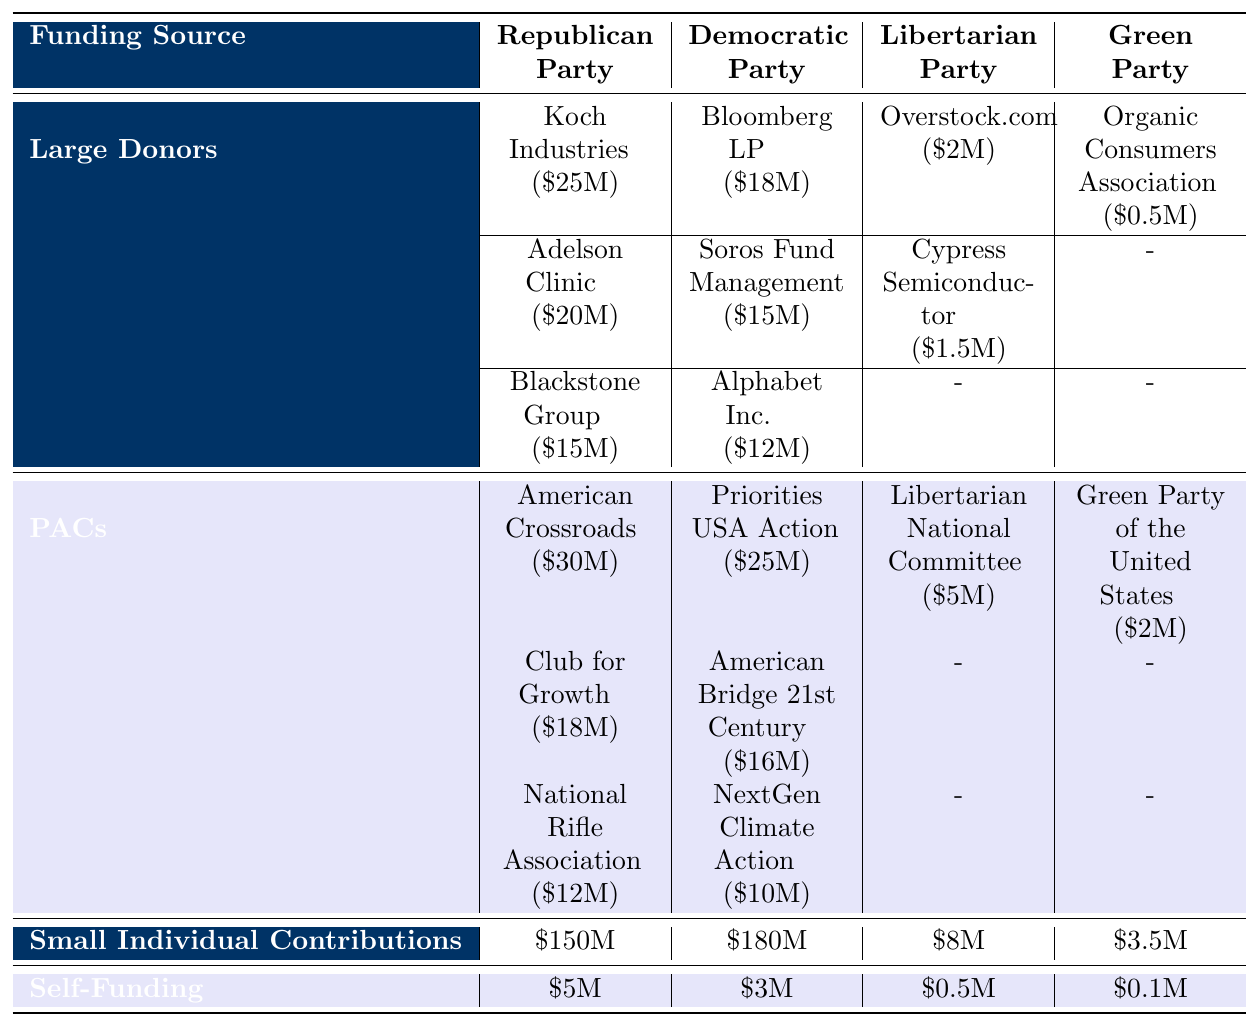What is the total amount from large donors for the Republican Party? The table shows the amounts from large donors to the Republican Party: Koch Industries ($25M), Adelson Clinic ($20M), and Blackstone Group ($15M). Adding these amounts gives $25M + $20M + $15M = $60M.
Answer: $60M Which party has the highest amount of small individual contributions? The table lists the small individual contributions for each party: Republican Party ($150M), Democratic Party ($180M), Libertarian Party ($8M), and Green Party ($3.5M). The Democratic Party has the highest amount at $180M.
Answer: Democratic Party Is the Libertarian Party's self-funding greater than that of the Green Party? The table shows the self-funding for both parties: Libertarian Party has $0.5M and Green Party has $0.1M. Since $0.5M is greater than $0.1M, the statement is true.
Answer: Yes What is the total funding for the Democratic Party from PACs? According to the table, the PACs for the Democratic Party have the following amounts: Priorities USA Action ($25M), American Bridge 21st Century ($16M), and NextGen Climate Action ($10M). Adding these gives $25M + $16M + $10M = $51M.
Answer: $51M Which party received the least funding from large donors? The table identifies the amounts from large donors for each party: Republican Party ($60M), Democratic Party ($45M), Libertarian Party ($3.5M), and Green Party ($0.5M). The Green Party received the least funding at $0.5M.
Answer: Green Party What is the difference in total small individual contributions between the Republican and Green parties? The small individual contributions for the Republican Party is $150M and for the Green Party is $3.5M. The difference can be calculated as $150M - $3.5M = $146.5M.
Answer: $146.5M Do any of the parties have no amounts listed for large donors? The table shows that the Green Party has no amounts listed for large donors as there are no entries in that section. Thus, the statement is true.
Answer: Yes Which funding source provided the most significant amount for the Republican Party? According to the table, the highest amounts listed for the Republican Party are from large donors with $60M and PACs with $60M. Since both are equal and represent the highest, determining the fraction of funding from each source is needed for a final answer.
Answer: Large Donors and PACs What is the total amount of self-funding for all parties combined? The self-funding amounts are: Republican Party ($5M), Democratic Party ($3M), Libertarian Party ($0.5M), and Green Party ($0.1M). Summing these values gives $5M + $3M + $0.5M + $0.1M = $8.6M.
Answer: $8.6M 